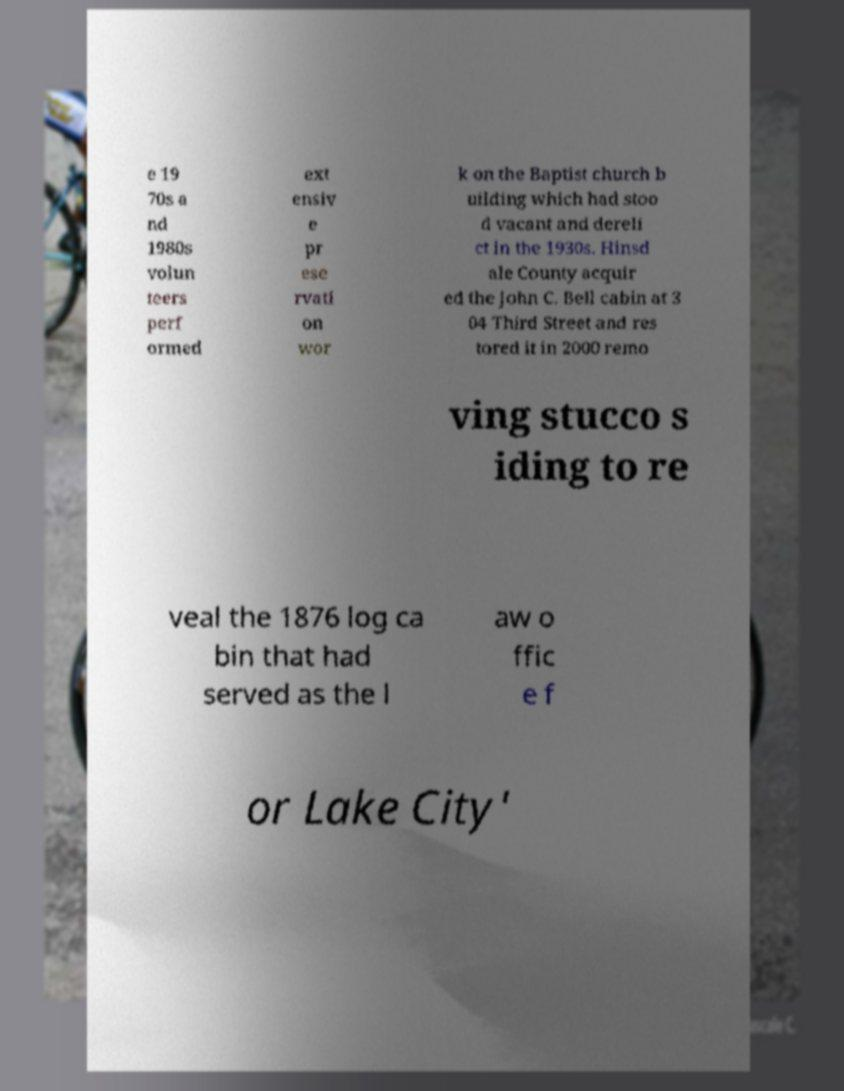I need the written content from this picture converted into text. Can you do that? e 19 70s a nd 1980s volun teers perf ormed ext ensiv e pr ese rvati on wor k on the Baptist church b uilding which had stoo d vacant and dereli ct in the 1930s. Hinsd ale County acquir ed the John C. Bell cabin at 3 04 Third Street and res tored it in 2000 remo ving stucco s iding to re veal the 1876 log ca bin that had served as the l aw o ffic e f or Lake City' 